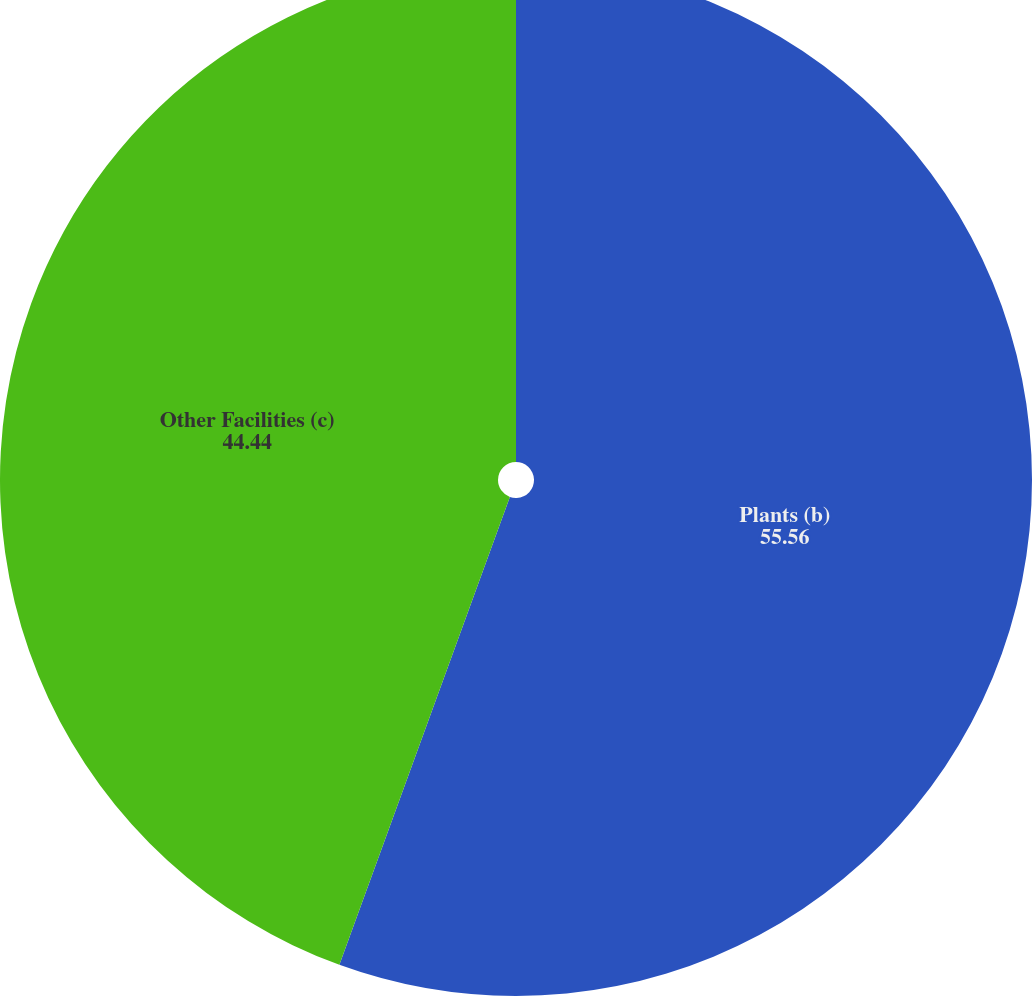Convert chart to OTSL. <chart><loc_0><loc_0><loc_500><loc_500><pie_chart><fcel>Plants (b)<fcel>Other Facilities (c)<nl><fcel>55.56%<fcel>44.44%<nl></chart> 